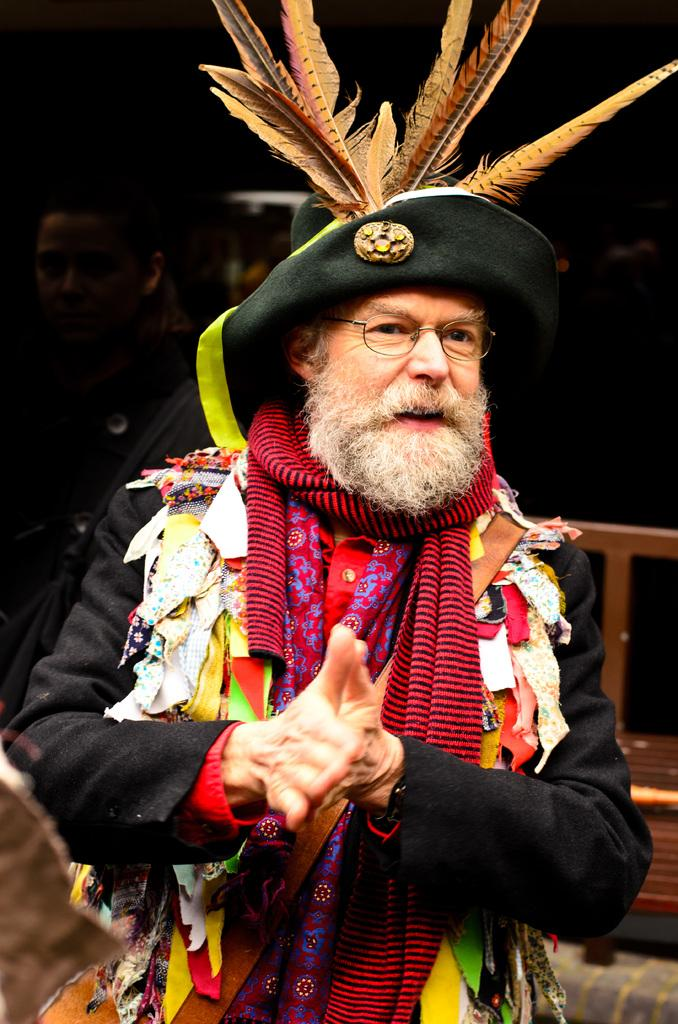What is the main subject of the image? The main subject of the image is a man standing. What is the man wearing in the image? The man is wearing a hat in the image. What can be observed about the background of the image? The background of the image is dark. What type of insurance policy is advertised on the sign in the image? There is no sign present in the image, so it is not possible to determine if any insurance policy is advertised. 